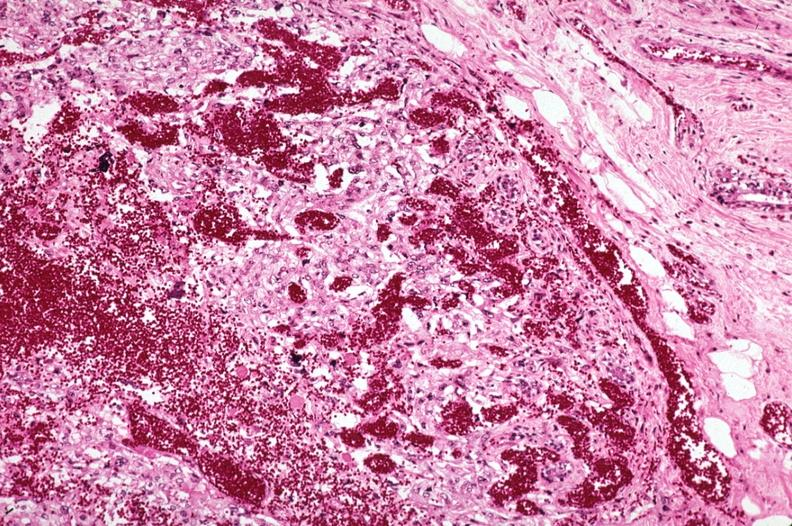does natural color show metastatic choriocarcinoma with extensive vascularization?
Answer the question using a single word or phrase. No 